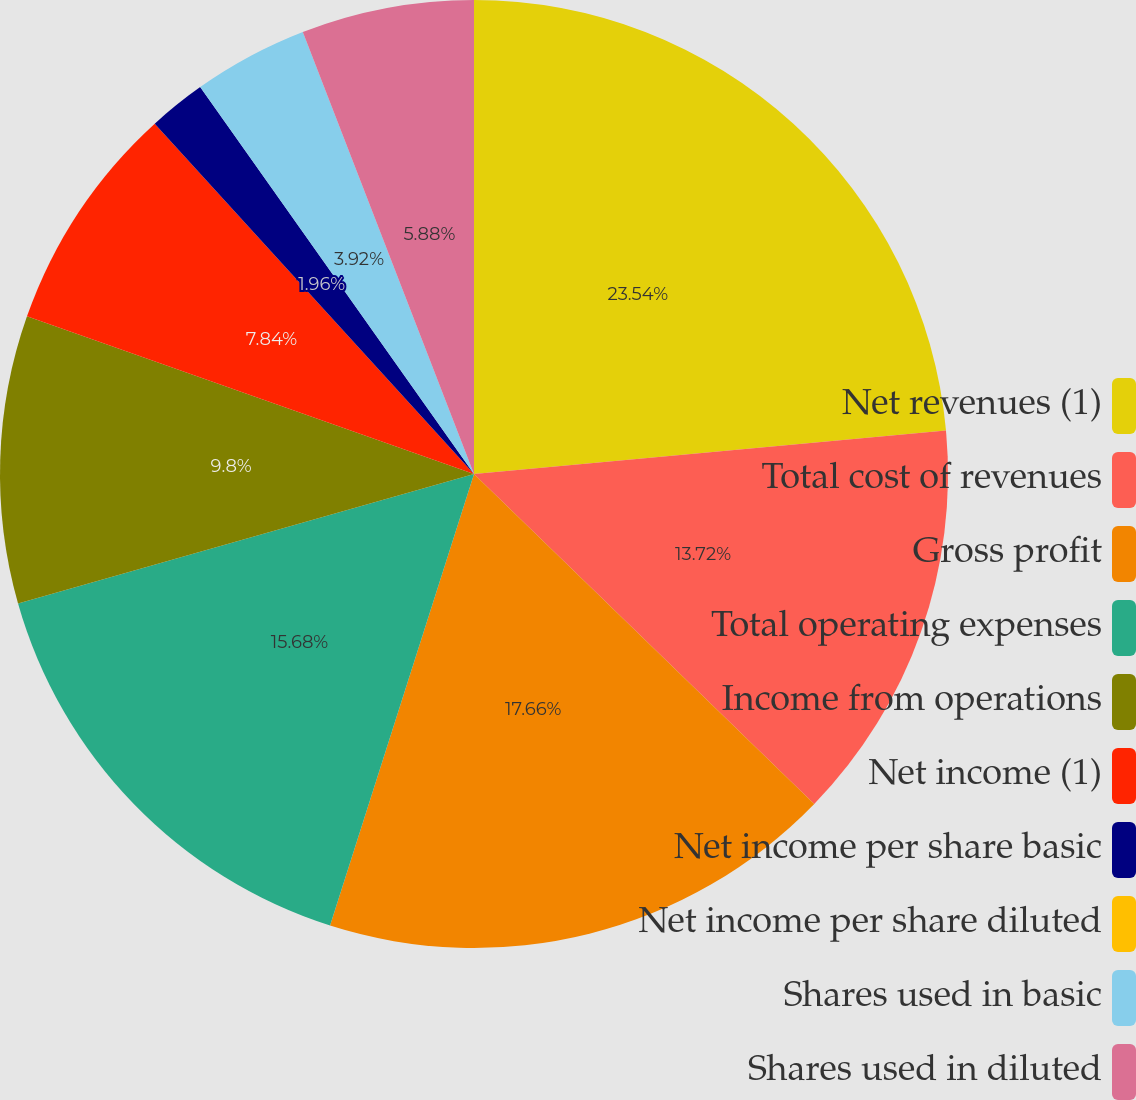Convert chart to OTSL. <chart><loc_0><loc_0><loc_500><loc_500><pie_chart><fcel>Net revenues (1)<fcel>Total cost of revenues<fcel>Gross profit<fcel>Total operating expenses<fcel>Income from operations<fcel>Net income (1)<fcel>Net income per share basic<fcel>Net income per share diluted<fcel>Shares used in basic<fcel>Shares used in diluted<nl><fcel>23.53%<fcel>13.72%<fcel>17.65%<fcel>15.68%<fcel>9.8%<fcel>7.84%<fcel>1.96%<fcel>0.0%<fcel>3.92%<fcel>5.88%<nl></chart> 